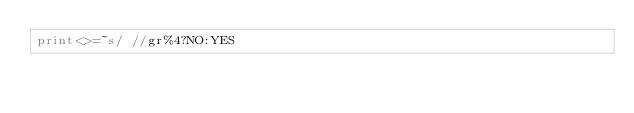<code> <loc_0><loc_0><loc_500><loc_500><_Perl_>print<>=~s/ //gr%4?NO:YES</code> 